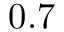<formula> <loc_0><loc_0><loc_500><loc_500>0 . 7</formula> 